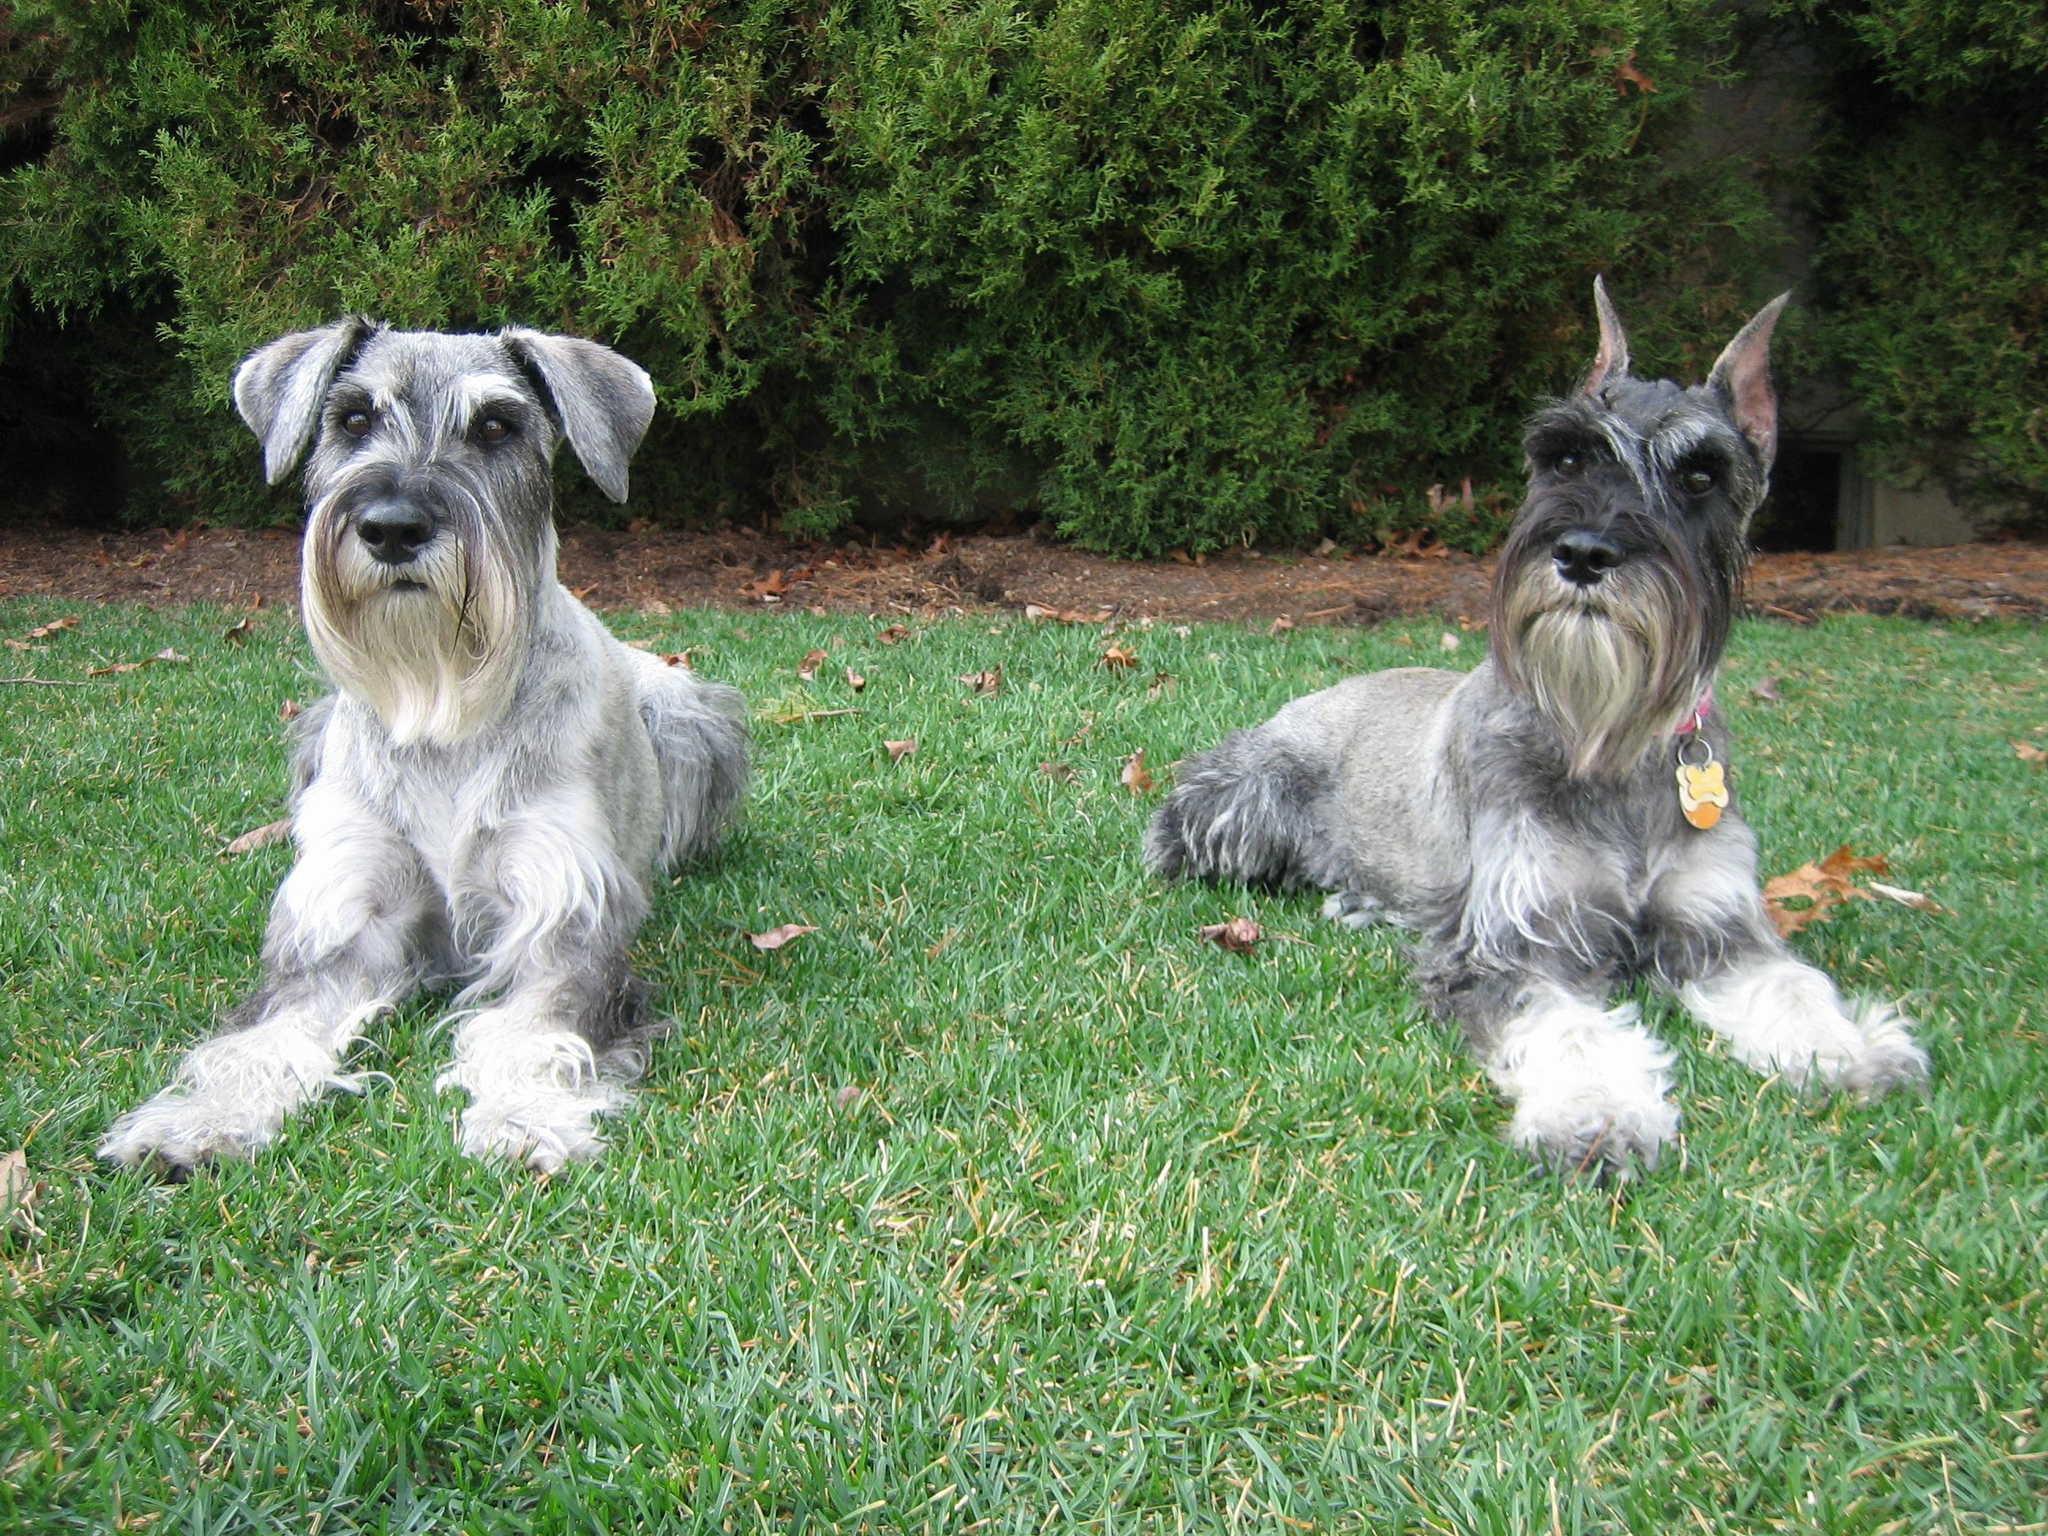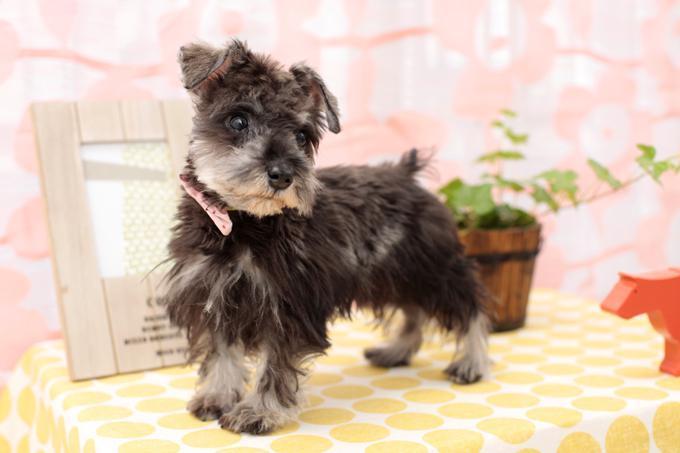The first image is the image on the left, the second image is the image on the right. Examine the images to the left and right. Is the description "AT least one dog is wearing a collar." accurate? Answer yes or no. Yes. The first image is the image on the left, the second image is the image on the right. For the images displayed, is the sentence "The dog in the left image is facing towards the right." factually correct? Answer yes or no. No. 